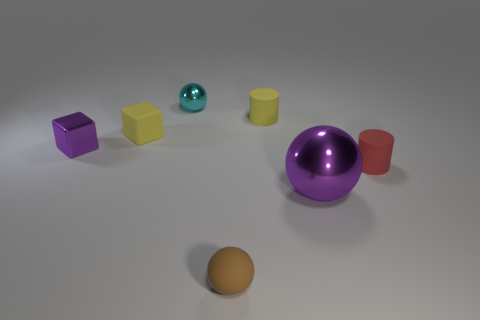Add 1 purple metallic cubes. How many objects exist? 8 Subtract all spheres. How many objects are left? 4 Subtract 1 cyan spheres. How many objects are left? 6 Subtract all purple objects. Subtract all tiny blocks. How many objects are left? 3 Add 5 brown things. How many brown things are left? 6 Add 4 cyan metal things. How many cyan metal things exist? 5 